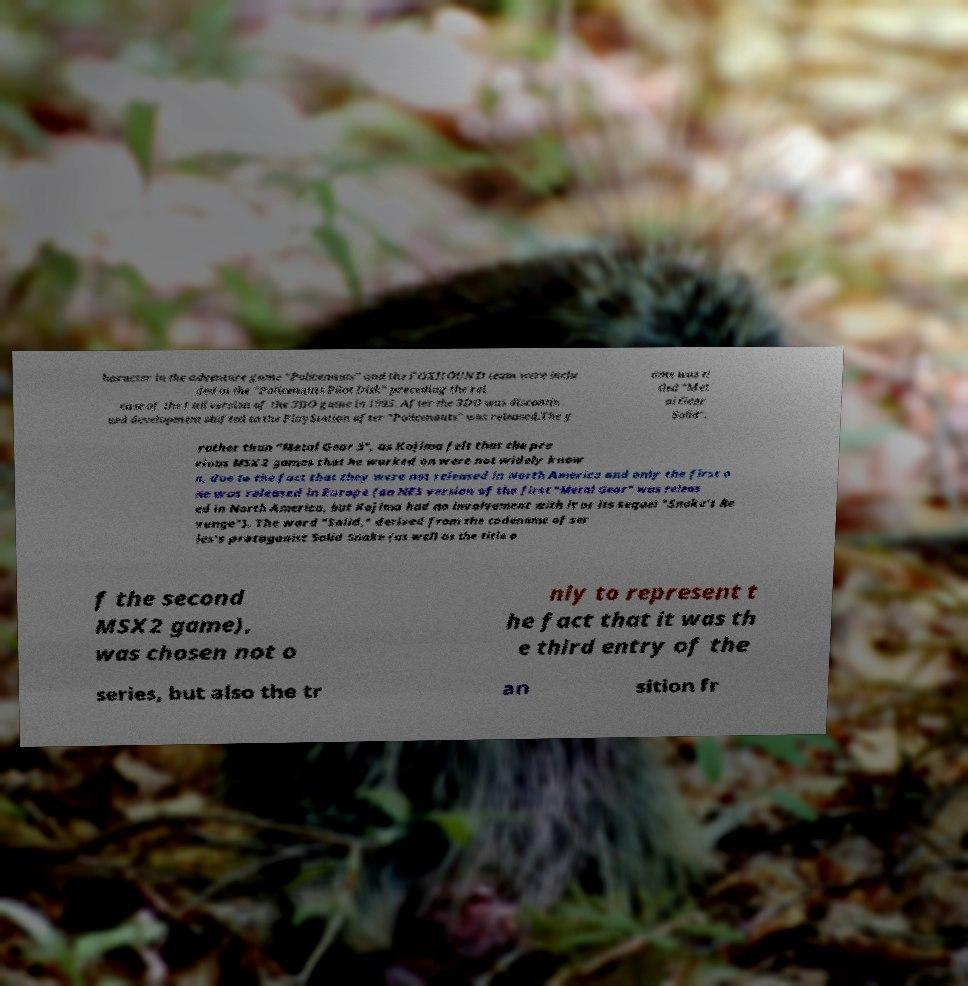Could you assist in decoding the text presented in this image and type it out clearly? haracter in the adventure game "Policenauts" and the FOXHOUND team were inclu ded in the "Policenauts Pilot Disk" preceding the rel ease of the full version of the 3DO game in 1995. After the 3DO was discontin ued development shifted to the PlayStation after "Policenauts" was released.The g ame was ti tled "Met al Gear Solid", rather than "Metal Gear 3", as Kojima felt that the pre vious MSX2 games that he worked on were not widely know n, due to the fact that they were not released in North America and only the first o ne was released in Europe (an NES version of the first "Metal Gear" was releas ed in North America, but Kojima had no involvement with it or its sequel "Snake's Re venge"). The word "Solid," derived from the codename of ser ies's protagonist Solid Snake (as well as the title o f the second MSX2 game), was chosen not o nly to represent t he fact that it was th e third entry of the series, but also the tr an sition fr 